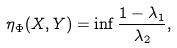Convert formula to latex. <formula><loc_0><loc_0><loc_500><loc_500>\eta _ { \Phi } ( X , Y ) = \inf \frac { 1 - \lambda _ { 1 } } { \lambda _ { 2 } } ,</formula> 